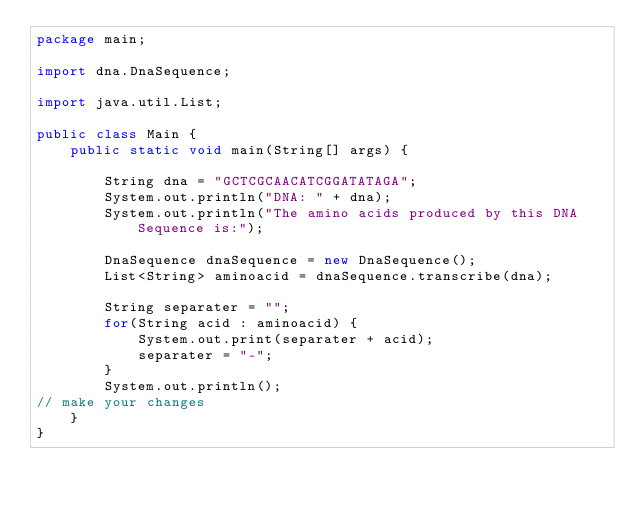<code> <loc_0><loc_0><loc_500><loc_500><_Java_>package main;

import dna.DnaSequence;

import java.util.List;

public class Main {
    public static void main(String[] args) {

        String dna = "GCTCGCAACATCGGATATAGA";
        System.out.println("DNA: " + dna);
        System.out.println("The amino acids produced by this DNA Sequence is:");

        DnaSequence dnaSequence = new DnaSequence();
        List<String> aminoacid = dnaSequence.transcribe(dna);

        String separater = "";
        for(String acid : aminoacid) {
            System.out.print(separater + acid);
            separater = "-";
        }
        System.out.println();
// make your changes
    }
}
</code> 